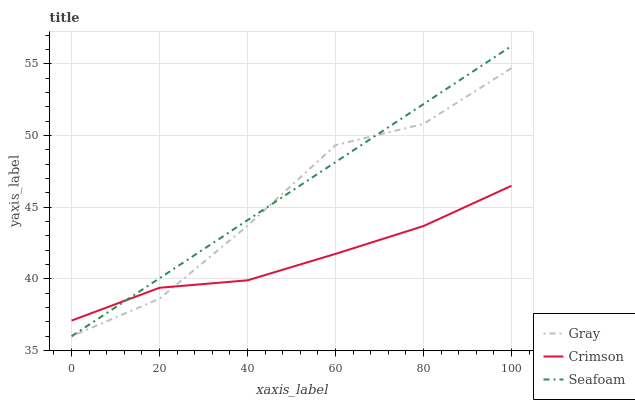Does Crimson have the minimum area under the curve?
Answer yes or no. Yes. Does Seafoam have the maximum area under the curve?
Answer yes or no. Yes. Does Gray have the minimum area under the curve?
Answer yes or no. No. Does Gray have the maximum area under the curve?
Answer yes or no. No. Is Seafoam the smoothest?
Answer yes or no. Yes. Is Gray the roughest?
Answer yes or no. Yes. Is Gray the smoothest?
Answer yes or no. No. Is Seafoam the roughest?
Answer yes or no. No. Does Gray have the lowest value?
Answer yes or no. Yes. Does Seafoam have the highest value?
Answer yes or no. Yes. Does Gray have the highest value?
Answer yes or no. No. Does Gray intersect Seafoam?
Answer yes or no. Yes. Is Gray less than Seafoam?
Answer yes or no. No. Is Gray greater than Seafoam?
Answer yes or no. No. 